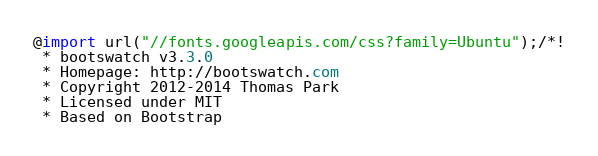Convert code to text. <code><loc_0><loc_0><loc_500><loc_500><_CSS_>@import url("//fonts.googleapis.com/css?family=Ubuntu");/*!
 * bootswatch v3.3.0
 * Homepage: http://bootswatch.com
 * Copyright 2012-2014 Thomas Park
 * Licensed under MIT
 * Based on Bootstrap</code> 